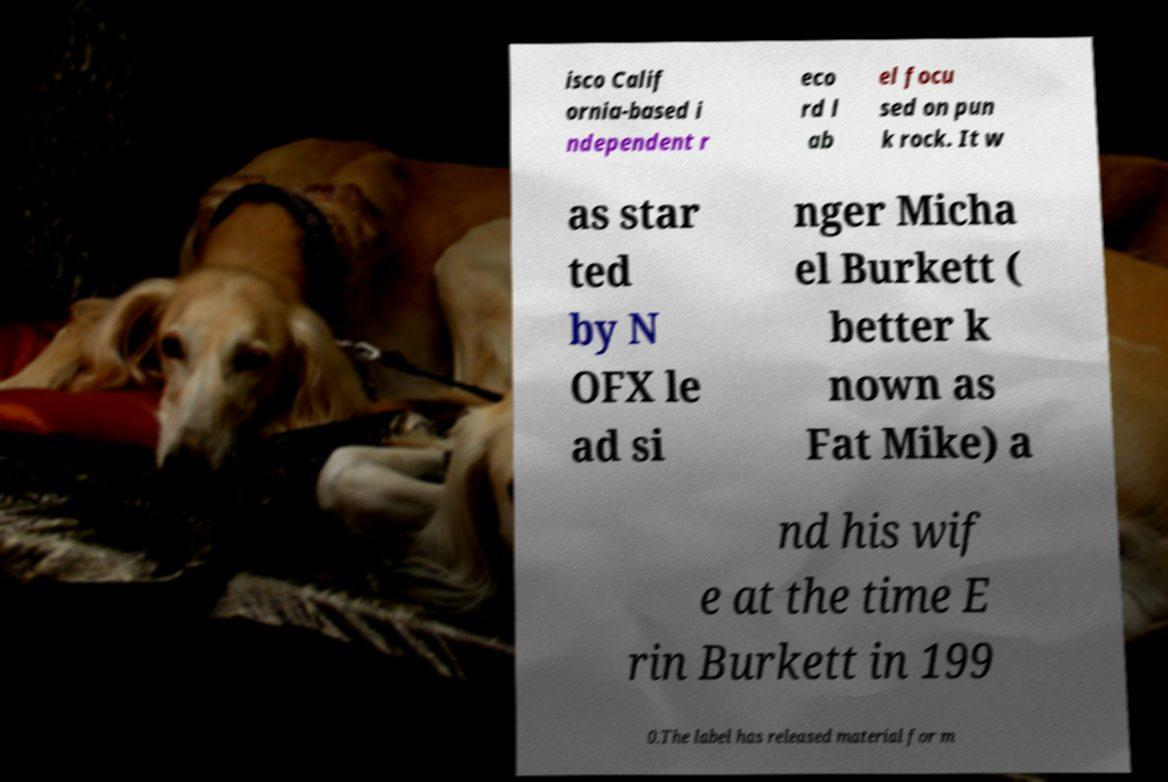Please read and relay the text visible in this image. What does it say? isco Calif ornia-based i ndependent r eco rd l ab el focu sed on pun k rock. It w as star ted by N OFX le ad si nger Micha el Burkett ( better k nown as Fat Mike) a nd his wif e at the time E rin Burkett in 199 0.The label has released material for m 